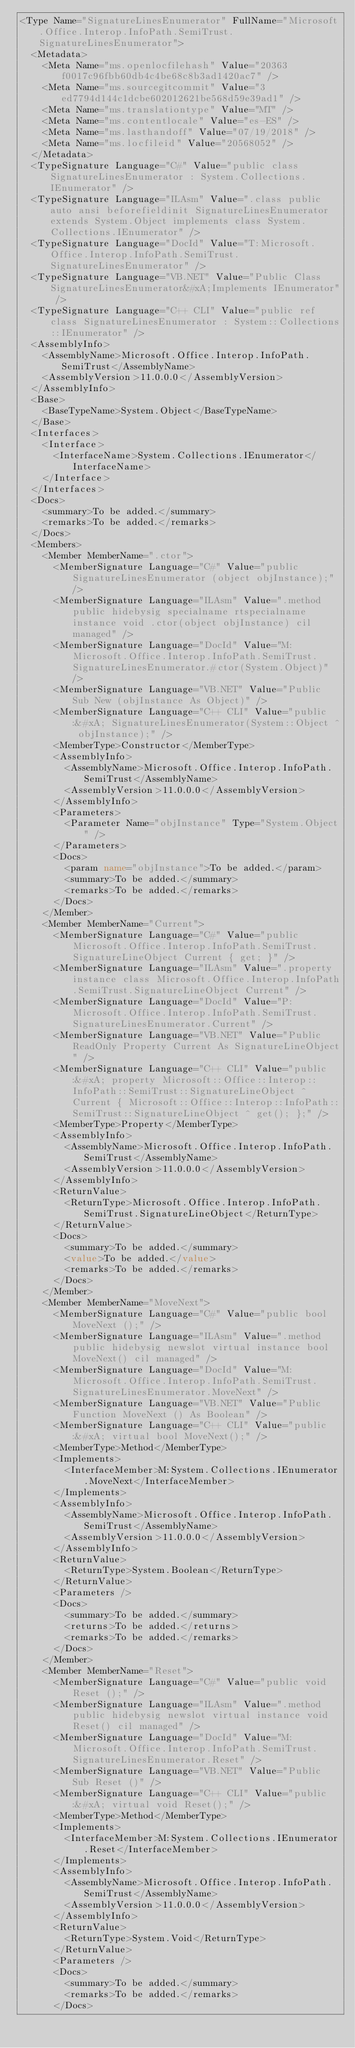Convert code to text. <code><loc_0><loc_0><loc_500><loc_500><_XML_><Type Name="SignatureLinesEnumerator" FullName="Microsoft.Office.Interop.InfoPath.SemiTrust.SignatureLinesEnumerator">
  <Metadata>
    <Meta Name="ms.openlocfilehash" Value="20363f0017c96fbb60db4c4be68c8b3ad1420ac7" />
    <Meta Name="ms.sourcegitcommit" Value="3ed7794d144c1dcbe602012621be568d59e39ad1" />
    <Meta Name="ms.translationtype" Value="MT" />
    <Meta Name="ms.contentlocale" Value="es-ES" />
    <Meta Name="ms.lasthandoff" Value="07/19/2018" />
    <Meta Name="ms.locfileid" Value="20568052" />
  </Metadata>
  <TypeSignature Language="C#" Value="public class SignatureLinesEnumerator : System.Collections.IEnumerator" />
  <TypeSignature Language="ILAsm" Value=".class public auto ansi beforefieldinit SignatureLinesEnumerator extends System.Object implements class System.Collections.IEnumerator" />
  <TypeSignature Language="DocId" Value="T:Microsoft.Office.Interop.InfoPath.SemiTrust.SignatureLinesEnumerator" />
  <TypeSignature Language="VB.NET" Value="Public Class SignatureLinesEnumerator&#xA;Implements IEnumerator" />
  <TypeSignature Language="C++ CLI" Value="public ref class SignatureLinesEnumerator : System::Collections::IEnumerator" />
  <AssemblyInfo>
    <AssemblyName>Microsoft.Office.Interop.InfoPath.SemiTrust</AssemblyName>
    <AssemblyVersion>11.0.0.0</AssemblyVersion>
  </AssemblyInfo>
  <Base>
    <BaseTypeName>System.Object</BaseTypeName>
  </Base>
  <Interfaces>
    <Interface>
      <InterfaceName>System.Collections.IEnumerator</InterfaceName>
    </Interface>
  </Interfaces>
  <Docs>
    <summary>To be added.</summary>
    <remarks>To be added.</remarks>
  </Docs>
  <Members>
    <Member MemberName=".ctor">
      <MemberSignature Language="C#" Value="public SignatureLinesEnumerator (object objInstance);" />
      <MemberSignature Language="ILAsm" Value=".method public hidebysig specialname rtspecialname instance void .ctor(object objInstance) cil managed" />
      <MemberSignature Language="DocId" Value="M:Microsoft.Office.Interop.InfoPath.SemiTrust.SignatureLinesEnumerator.#ctor(System.Object)" />
      <MemberSignature Language="VB.NET" Value="Public Sub New (objInstance As Object)" />
      <MemberSignature Language="C++ CLI" Value="public:&#xA; SignatureLinesEnumerator(System::Object ^ objInstance);" />
      <MemberType>Constructor</MemberType>
      <AssemblyInfo>
        <AssemblyName>Microsoft.Office.Interop.InfoPath.SemiTrust</AssemblyName>
        <AssemblyVersion>11.0.0.0</AssemblyVersion>
      </AssemblyInfo>
      <Parameters>
        <Parameter Name="objInstance" Type="System.Object" />
      </Parameters>
      <Docs>
        <param name="objInstance">To be added.</param>
        <summary>To be added.</summary>
        <remarks>To be added.</remarks>
      </Docs>
    </Member>
    <Member MemberName="Current">
      <MemberSignature Language="C#" Value="public Microsoft.Office.Interop.InfoPath.SemiTrust.SignatureLineObject Current { get; }" />
      <MemberSignature Language="ILAsm" Value=".property instance class Microsoft.Office.Interop.InfoPath.SemiTrust.SignatureLineObject Current" />
      <MemberSignature Language="DocId" Value="P:Microsoft.Office.Interop.InfoPath.SemiTrust.SignatureLinesEnumerator.Current" />
      <MemberSignature Language="VB.NET" Value="Public ReadOnly Property Current As SignatureLineObject" />
      <MemberSignature Language="C++ CLI" Value="public:&#xA; property Microsoft::Office::Interop::InfoPath::SemiTrust::SignatureLineObject ^ Current { Microsoft::Office::Interop::InfoPath::SemiTrust::SignatureLineObject ^ get(); };" />
      <MemberType>Property</MemberType>
      <AssemblyInfo>
        <AssemblyName>Microsoft.Office.Interop.InfoPath.SemiTrust</AssemblyName>
        <AssemblyVersion>11.0.0.0</AssemblyVersion>
      </AssemblyInfo>
      <ReturnValue>
        <ReturnType>Microsoft.Office.Interop.InfoPath.SemiTrust.SignatureLineObject</ReturnType>
      </ReturnValue>
      <Docs>
        <summary>To be added.</summary>
        <value>To be added.</value>
        <remarks>To be added.</remarks>
      </Docs>
    </Member>
    <Member MemberName="MoveNext">
      <MemberSignature Language="C#" Value="public bool MoveNext ();" />
      <MemberSignature Language="ILAsm" Value=".method public hidebysig newslot virtual instance bool MoveNext() cil managed" />
      <MemberSignature Language="DocId" Value="M:Microsoft.Office.Interop.InfoPath.SemiTrust.SignatureLinesEnumerator.MoveNext" />
      <MemberSignature Language="VB.NET" Value="Public Function MoveNext () As Boolean" />
      <MemberSignature Language="C++ CLI" Value="public:&#xA; virtual bool MoveNext();" />
      <MemberType>Method</MemberType>
      <Implements>
        <InterfaceMember>M:System.Collections.IEnumerator.MoveNext</InterfaceMember>
      </Implements>
      <AssemblyInfo>
        <AssemblyName>Microsoft.Office.Interop.InfoPath.SemiTrust</AssemblyName>
        <AssemblyVersion>11.0.0.0</AssemblyVersion>
      </AssemblyInfo>
      <ReturnValue>
        <ReturnType>System.Boolean</ReturnType>
      </ReturnValue>
      <Parameters />
      <Docs>
        <summary>To be added.</summary>
        <returns>To be added.</returns>
        <remarks>To be added.</remarks>
      </Docs>
    </Member>
    <Member MemberName="Reset">
      <MemberSignature Language="C#" Value="public void Reset ();" />
      <MemberSignature Language="ILAsm" Value=".method public hidebysig newslot virtual instance void Reset() cil managed" />
      <MemberSignature Language="DocId" Value="M:Microsoft.Office.Interop.InfoPath.SemiTrust.SignatureLinesEnumerator.Reset" />
      <MemberSignature Language="VB.NET" Value="Public Sub Reset ()" />
      <MemberSignature Language="C++ CLI" Value="public:&#xA; virtual void Reset();" />
      <MemberType>Method</MemberType>
      <Implements>
        <InterfaceMember>M:System.Collections.IEnumerator.Reset</InterfaceMember>
      </Implements>
      <AssemblyInfo>
        <AssemblyName>Microsoft.Office.Interop.InfoPath.SemiTrust</AssemblyName>
        <AssemblyVersion>11.0.0.0</AssemblyVersion>
      </AssemblyInfo>
      <ReturnValue>
        <ReturnType>System.Void</ReturnType>
      </ReturnValue>
      <Parameters />
      <Docs>
        <summary>To be added.</summary>
        <remarks>To be added.</remarks>
      </Docs></code> 